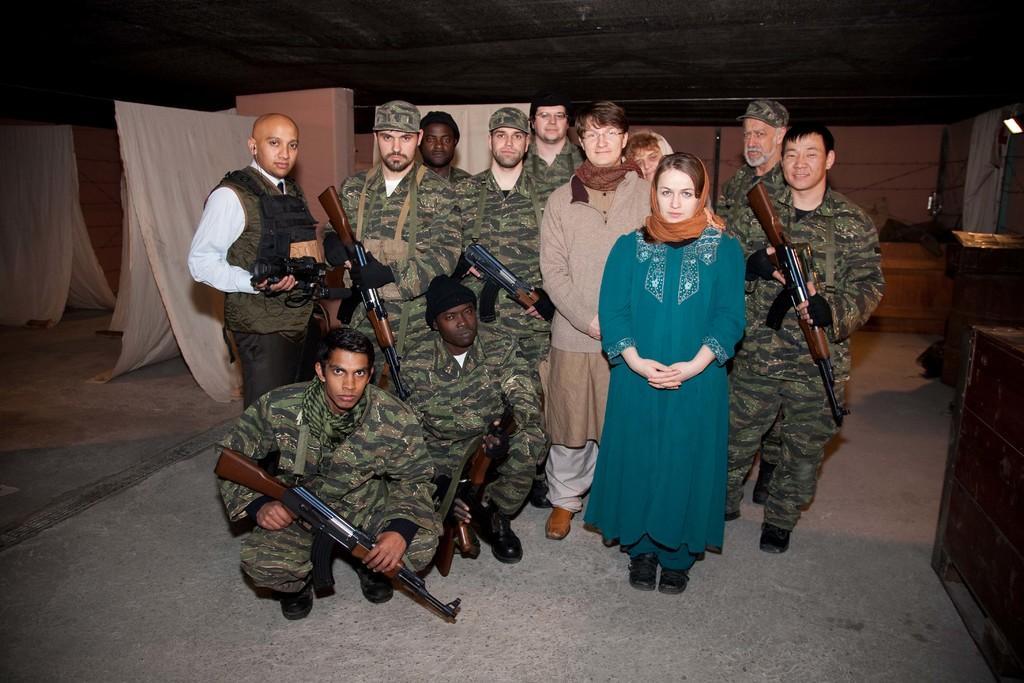Can you describe this image briefly? In this picture I can see group of people, there are few people holding rifles, and in the background there are clothes and some other objects. 